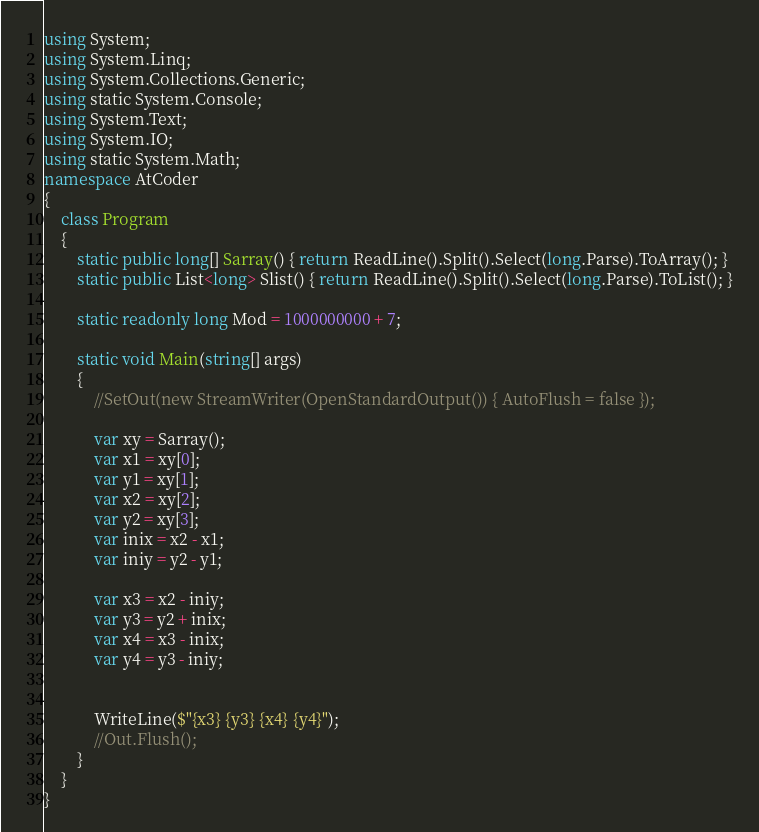Convert code to text. <code><loc_0><loc_0><loc_500><loc_500><_C#_>using System;
using System.Linq;
using System.Collections.Generic;
using static System.Console;
using System.Text;
using System.IO;
using static System.Math;
namespace AtCoder
{
    class Program
    {
        static public long[] Sarray() { return ReadLine().Split().Select(long.Parse).ToArray(); }
        static public List<long> Slist() { return ReadLine().Split().Select(long.Parse).ToList(); }

        static readonly long Mod = 1000000000 + 7;

        static void Main(string[] args)
        {
            //SetOut(new StreamWriter(OpenStandardOutput()) { AutoFlush = false });

            var xy = Sarray();
            var x1 = xy[0];
            var y1 = xy[1];
            var x2 = xy[2];
            var y2 = xy[3];
            var inix = x2 - x1;
            var iniy = y2 - y1;
            
            var x3 = x2 - iniy;
            var y3 = y2 + inix;
            var x4 = x3 - inix;
            var y4 = y3 - iniy;


            WriteLine($"{x3} {y3} {x4} {y4}");
            //Out.Flush();
        }
    }
}</code> 